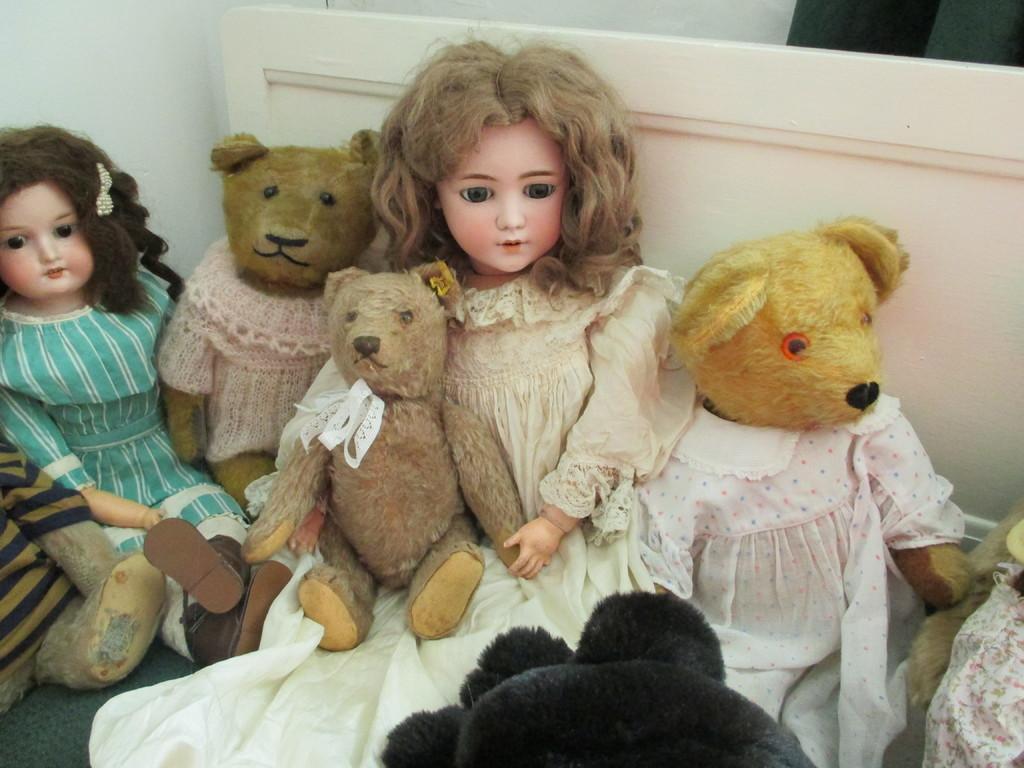Please provide a concise description of this image. In this image we can see a group of dolls which are placed on the floor. On the backside we can see a board and a wall. 